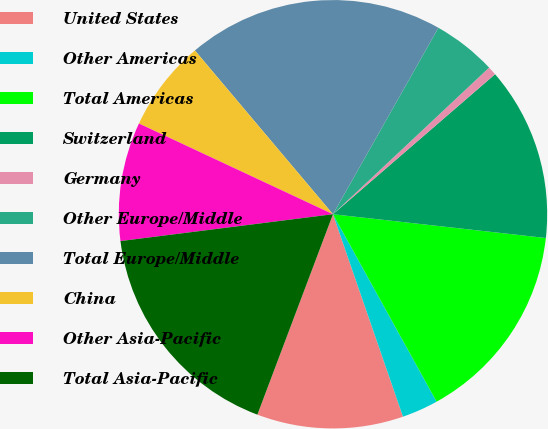Convert chart. <chart><loc_0><loc_0><loc_500><loc_500><pie_chart><fcel>United States<fcel>Other Americas<fcel>Total Americas<fcel>Switzerland<fcel>Germany<fcel>Other Europe/Middle<fcel>Total Europe/Middle<fcel>China<fcel>Other Asia-Pacific<fcel>Total Asia-Pacific<nl><fcel>11.04%<fcel>2.74%<fcel>15.19%<fcel>13.11%<fcel>0.66%<fcel>4.81%<fcel>19.34%<fcel>6.89%<fcel>8.96%<fcel>17.26%<nl></chart> 